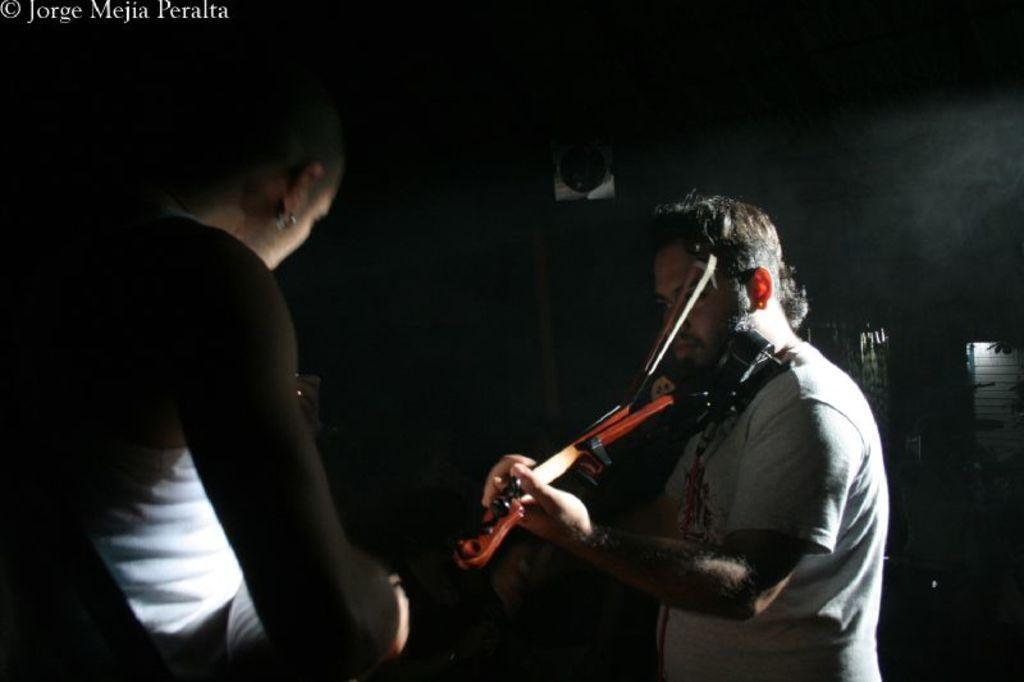Describe this image in one or two sentences. In this image there is a man standing towards the bottom of the image, he is playing a musical instrument, there is a woman standing towards the bottom of the image, there is an object towards the right of the image that looks like a wall, there is text towards the top of the image, the background of the image is dark. 